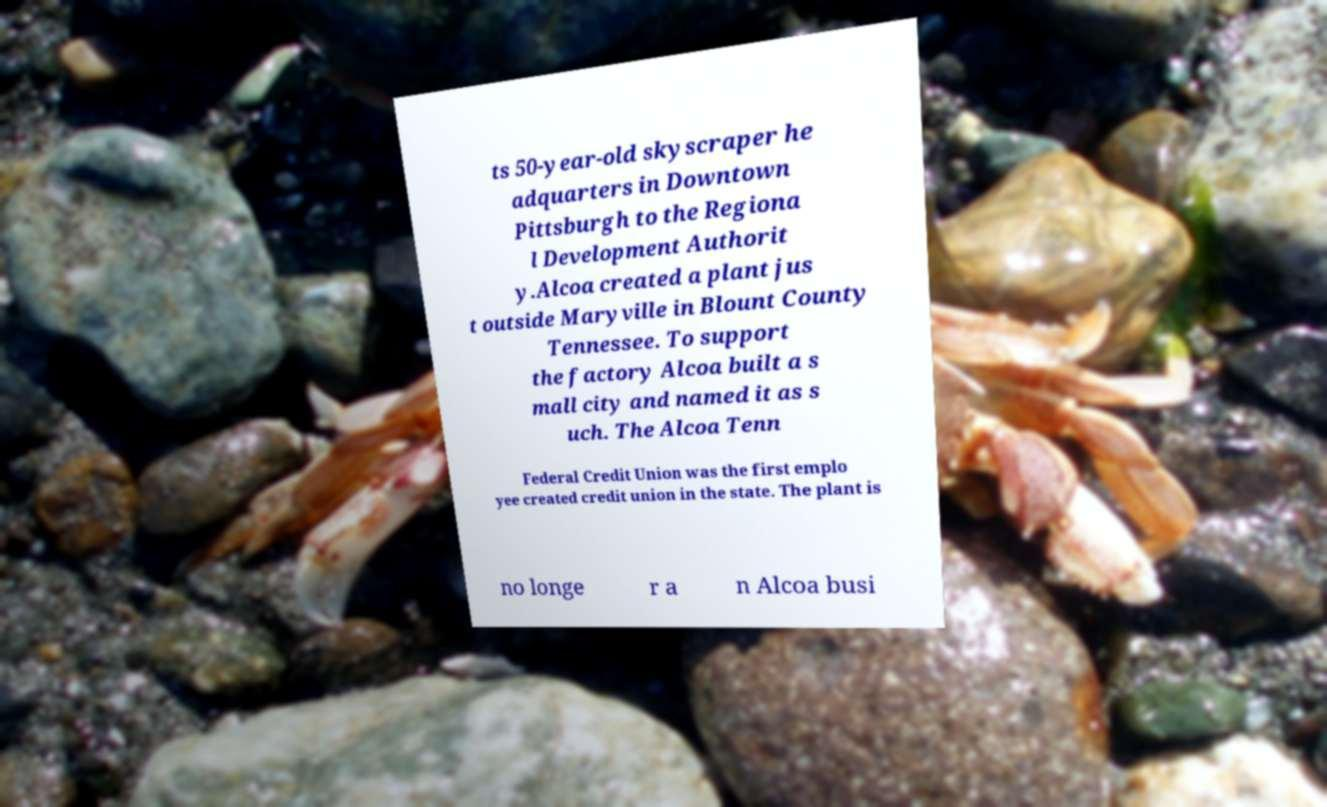Could you assist in decoding the text presented in this image and type it out clearly? ts 50-year-old skyscraper he adquarters in Downtown Pittsburgh to the Regiona l Development Authorit y.Alcoa created a plant jus t outside Maryville in Blount County Tennessee. To support the factory Alcoa built a s mall city and named it as s uch. The Alcoa Tenn Federal Credit Union was the first emplo yee created credit union in the state. The plant is no longe r a n Alcoa busi 